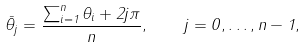<formula> <loc_0><loc_0><loc_500><loc_500>\bar { \theta } _ { j } = \frac { \sum _ { i = 1 } ^ { n } \theta _ { i } + 2 j \pi } { n } , \quad j = 0 , \dots , n - 1 ,</formula> 